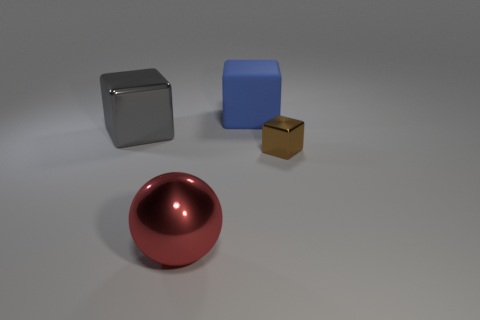There is a thing that is in front of the shiny block that is in front of the big shiny thing that is behind the big red ball; what is its size?
Offer a very short reply. Large. There is another gray thing that is the same shape as the matte object; what size is it?
Provide a short and direct response. Large. How many tiny shiny blocks are right of the small brown block?
Ensure brevity in your answer.  0. Does the big thing to the left of the large red metal object have the same color as the small block?
Your answer should be very brief. No. What number of cyan objects are large metallic things or tiny cubes?
Make the answer very short. 0. What color is the shiny cube right of the metal cube that is behind the small cube?
Offer a terse response. Brown. There is a big object in front of the small brown metal thing; what color is it?
Keep it short and to the point. Red. There is a metallic cube to the left of the brown shiny block; is it the same size as the red thing?
Offer a very short reply. Yes. Are there any red objects of the same size as the brown metallic object?
Offer a very short reply. No. There is a big object that is behind the gray cube; does it have the same color as the metallic cube that is to the left of the brown metal thing?
Make the answer very short. No. 